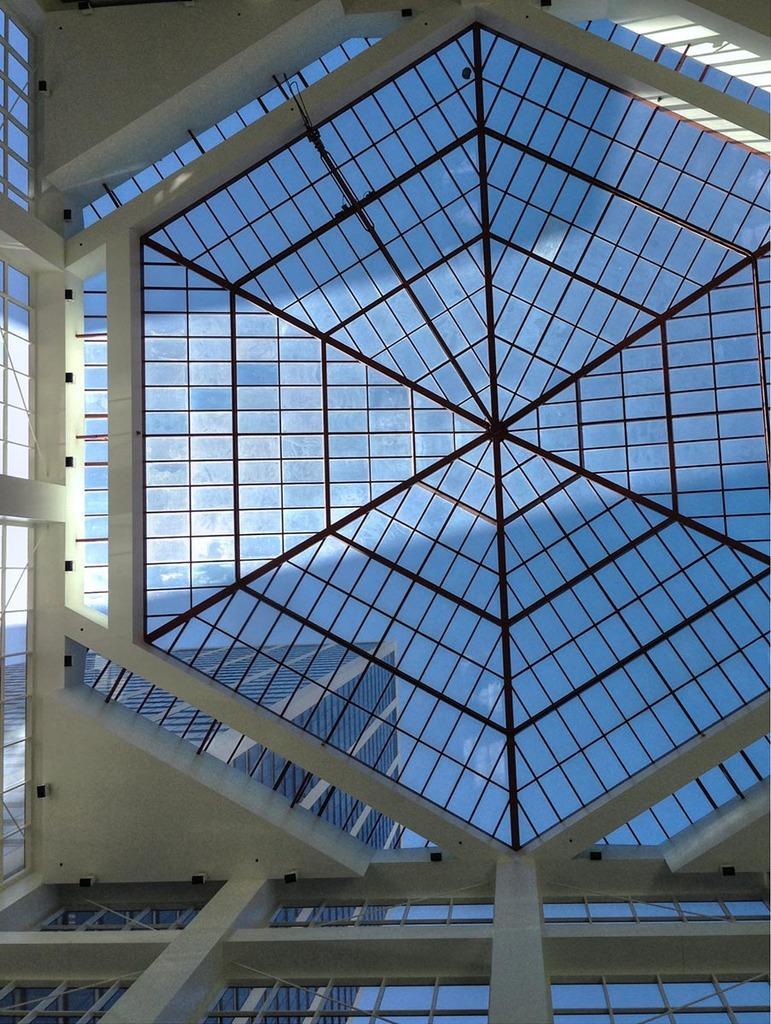Can you describe this image briefly? In the image we can see the construction made up of glass. Here we can see the building and the sky. 